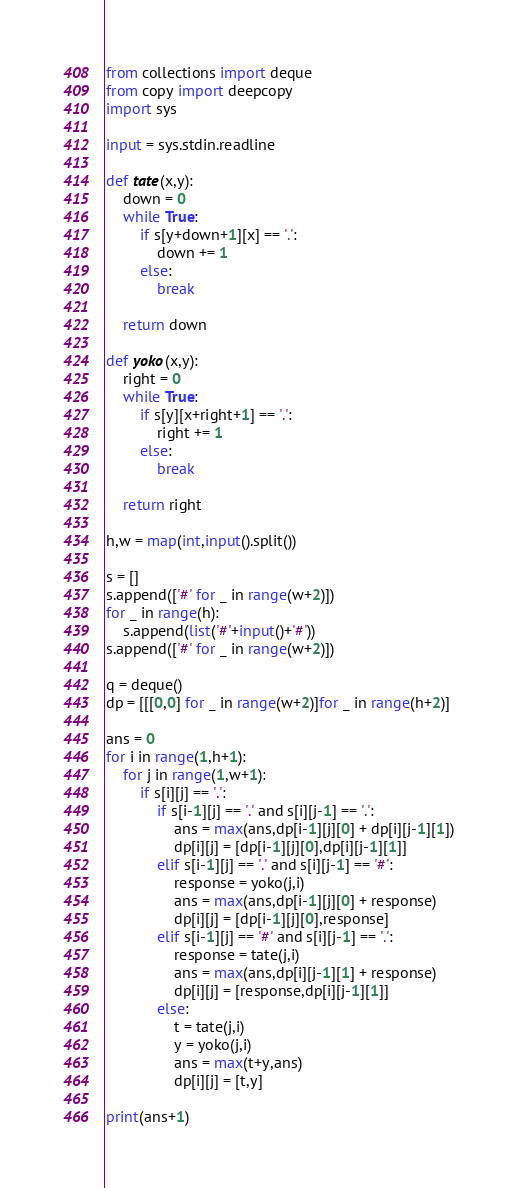Convert code to text. <code><loc_0><loc_0><loc_500><loc_500><_Python_>from collections import deque
from copy import deepcopy
import sys

input = sys.stdin.readline

def tate(x,y):
    down = 0
    while True:
        if s[y+down+1][x] == '.':
            down += 1
        else:
            break

    return down

def yoko(x,y):
    right = 0
    while True:
        if s[y][x+right+1] == '.':
            right += 1
        else:
            break

    return right

h,w = map(int,input().split())

s = []
s.append(['#' for _ in range(w+2)])
for _ in range(h):
    s.append(list('#'+input()+'#'))
s.append(['#' for _ in range(w+2)])

q = deque()
dp = [[[0,0] for _ in range(w+2)]for _ in range(h+2)]

ans = 0
for i in range(1,h+1):
    for j in range(1,w+1):
        if s[i][j] == '.':
            if s[i-1][j] == '.' and s[i][j-1] == '.':
                ans = max(ans,dp[i-1][j][0] + dp[i][j-1][1])
                dp[i][j] = [dp[i-1][j][0],dp[i][j-1][1]]
            elif s[i-1][j] == '.' and s[i][j-1] == '#':
                response = yoko(j,i)
                ans = max(ans,dp[i-1][j][0] + response)
                dp[i][j] = [dp[i-1][j][0],response]
            elif s[i-1][j] == '#' and s[i][j-1] == '.':
                response = tate(j,i)
                ans = max(ans,dp[i][j-1][1] + response)
                dp[i][j] = [response,dp[i][j-1][1]]
            else:
                t = tate(j,i)
                y = yoko(j,i)
                ans = max(t+y,ans)
                dp[i][j] = [t,y]

print(ans+1)
</code> 